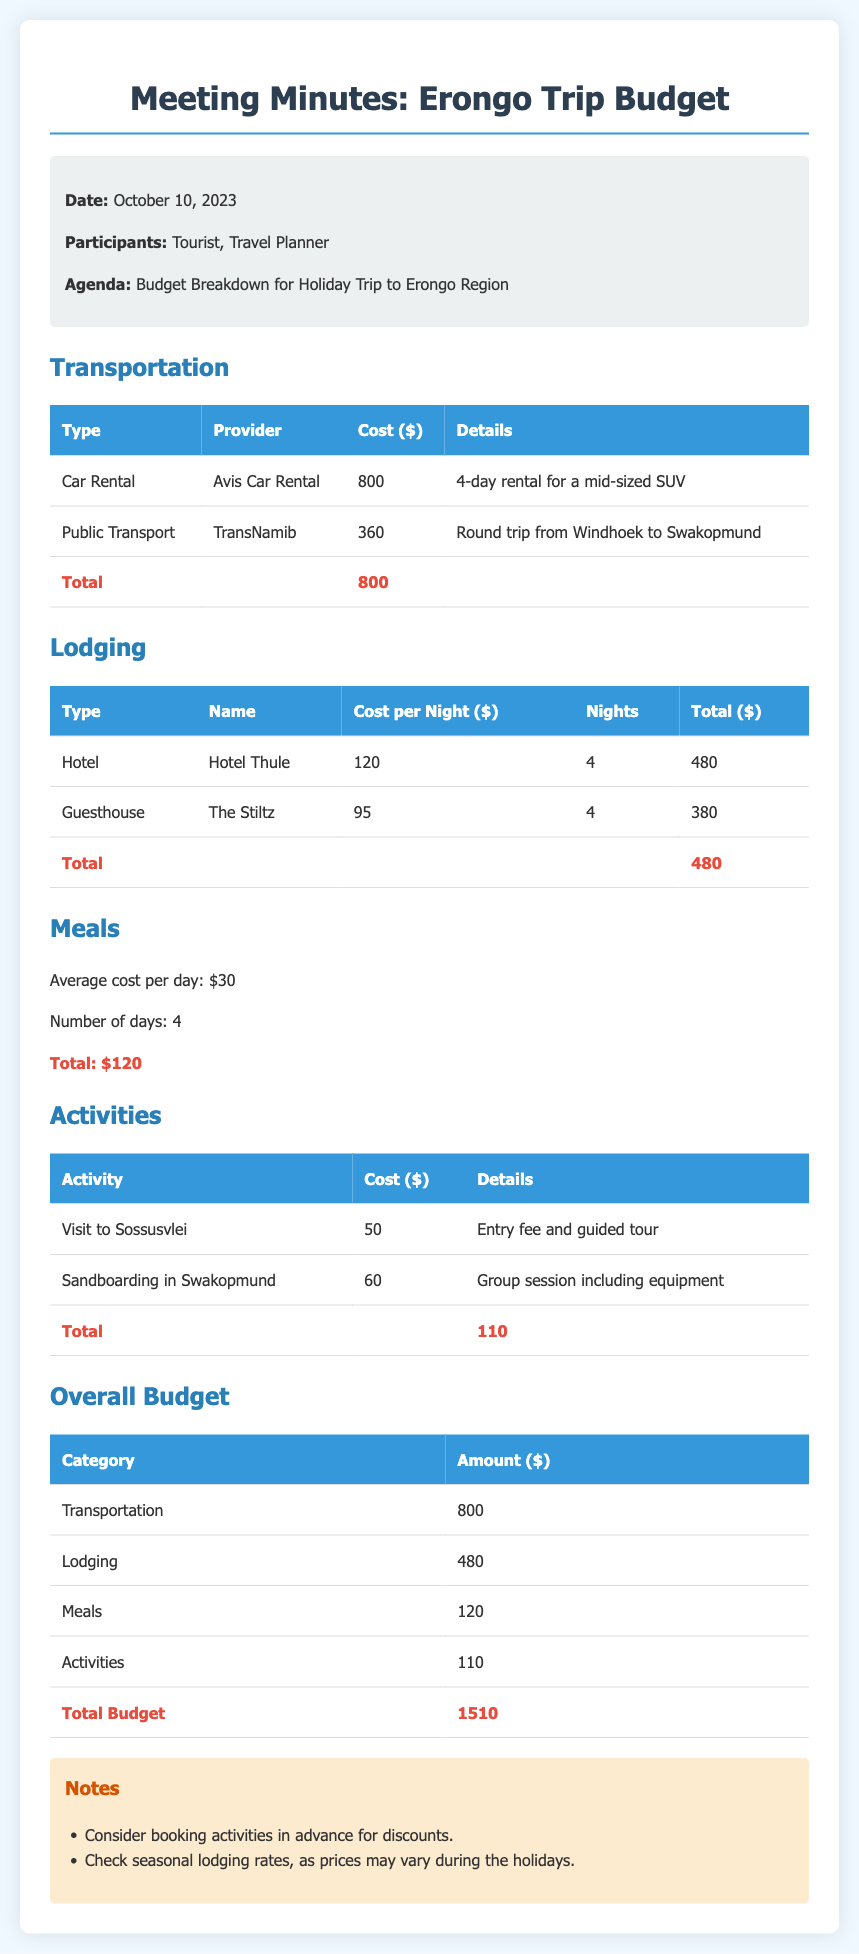What is the date of the meeting? The date of the meeting is specified in the document's header under "Date."
Answer: October 10, 2023 Who provided the car rental? The provider of the car rental is mentioned in the transportation section of the document.
Answer: Avis Car Rental What is the total cost for lodging? The total cost for lodging is calculated in the lodging section and noted in the document.
Answer: 480 What is the average cost of meals per day? The average cost of meals is mentioned in the meals section as part of the budget breakdown.
Answer: 30 What activities are included in the budget? The activities listed in the activities section provide details about what is included in the budget.
Answer: Visit to Sossusvlei, Sandboarding in Swakopmund What is the total budget for the trip? The overall budget summary at the end of the document compiles all categories to provide the total.
Answer: 1510 How many nights will be spent at Hotel Thule? The number of nights is detailed in the lodging section under the Hotel Thule entry.
Answer: 4 What should be considered for booking activities? The notes section provides recommendations related to booking activities, indicating what to consider.
Answer: Discounts What type of lodging is booked for this trip? The lodging section specifies the types of accommodations included in the budget for the trip.
Answer: Hotel, Guesthouse 